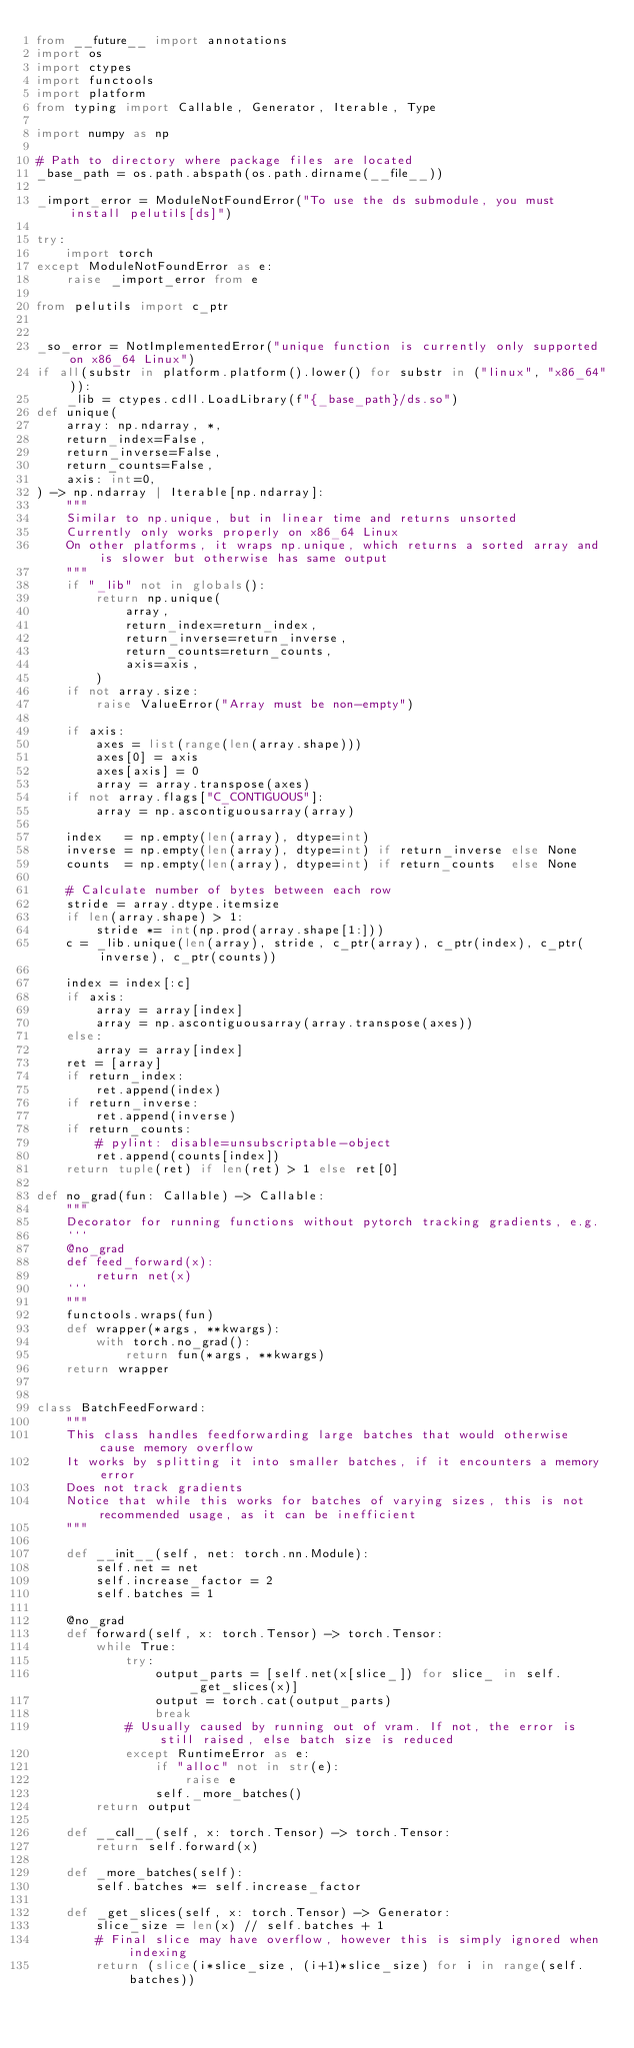Convert code to text. <code><loc_0><loc_0><loc_500><loc_500><_Python_>from __future__ import annotations
import os
import ctypes
import functools
import platform
from typing import Callable, Generator, Iterable, Type

import numpy as np

# Path to directory where package files are located
_base_path = os.path.abspath(os.path.dirname(__file__))

_import_error = ModuleNotFoundError("To use the ds submodule, you must install pelutils[ds]")

try:
    import torch
except ModuleNotFoundError as e:
    raise _import_error from e

from pelutils import c_ptr


_so_error = NotImplementedError("unique function is currently only supported on x86_64 Linux")
if all(substr in platform.platform().lower() for substr in ("linux", "x86_64")):
    _lib = ctypes.cdll.LoadLibrary(f"{_base_path}/ds.so")
def unique(
    array: np.ndarray, *,
    return_index=False,
    return_inverse=False,
    return_counts=False,
    axis: int=0,
) -> np.ndarray | Iterable[np.ndarray]:
    """
    Similar to np.unique, but in linear time and returns unsorted
    Currently only works properly on x86_64 Linux
    On other platforms, it wraps np.unique, which returns a sorted array and is slower but otherwise has same output
    """
    if "_lib" not in globals():
        return np.unique(
            array,
            return_index=return_index,
            return_inverse=return_inverse,
            return_counts=return_counts,
            axis=axis,
        )
    if not array.size:
        raise ValueError("Array must be non-empty")

    if axis:
        axes = list(range(len(array.shape)))
        axes[0] = axis
        axes[axis] = 0
        array = array.transpose(axes)
    if not array.flags["C_CONTIGUOUS"]:
        array = np.ascontiguousarray(array)

    index   = np.empty(len(array), dtype=int)
    inverse = np.empty(len(array), dtype=int) if return_inverse else None
    counts  = np.empty(len(array), dtype=int) if return_counts  else None

    # Calculate number of bytes between each row
    stride = array.dtype.itemsize
    if len(array.shape) > 1:
        stride *= int(np.prod(array.shape[1:]))
    c = _lib.unique(len(array), stride, c_ptr(array), c_ptr(index), c_ptr(inverse), c_ptr(counts))

    index = index[:c]
    if axis:
        array = array[index]
        array = np.ascontiguousarray(array.transpose(axes))
    else:
        array = array[index]
    ret = [array]
    if return_index:
        ret.append(index)
    if return_inverse:
        ret.append(inverse)
    if return_counts:
        # pylint: disable=unsubscriptable-object
        ret.append(counts[index])
    return tuple(ret) if len(ret) > 1 else ret[0]

def no_grad(fun: Callable) -> Callable:
    """
    Decorator for running functions without pytorch tracking gradients, e.g.
    ```
    @no_grad
    def feed_forward(x):
        return net(x)
    ```
    """
    functools.wraps(fun)
    def wrapper(*args, **kwargs):
        with torch.no_grad():
            return fun(*args, **kwargs)
    return wrapper


class BatchFeedForward:
    """
    This class handles feedforwarding large batches that would otherwise cause memory overflow
    It works by splitting it into smaller batches, if it encounters a memory error
    Does not track gradients
    Notice that while this works for batches of varying sizes, this is not recommended usage, as it can be inefficient
    """

    def __init__(self, net: torch.nn.Module):
        self.net = net
        self.increase_factor = 2
        self.batches = 1

    @no_grad
    def forward(self, x: torch.Tensor) -> torch.Tensor:
        while True:
            try:
                output_parts = [self.net(x[slice_]) for slice_ in self._get_slices(x)]
                output = torch.cat(output_parts)
                break
            # Usually caused by running out of vram. If not, the error is still raised, else batch size is reduced
            except RuntimeError as e:
                if "alloc" not in str(e):
                    raise e
                self._more_batches()
        return output

    def __call__(self, x: torch.Tensor) -> torch.Tensor:
        return self.forward(x)

    def _more_batches(self):
        self.batches *= self.increase_factor

    def _get_slices(self, x: torch.Tensor) -> Generator:
        slice_size = len(x) // self.batches + 1
        # Final slice may have overflow, however this is simply ignored when indexing
        return (slice(i*slice_size, (i+1)*slice_size) for i in range(self.batches))
</code> 